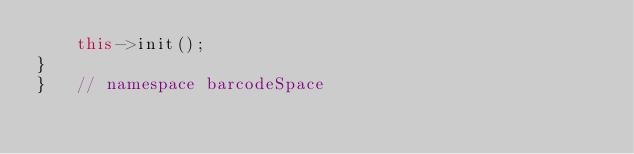Convert code to text. <code><loc_0><loc_0><loc_500><loc_500><_C++_>    this->init();
}
}   // namespace barcodeSpace
</code> 